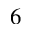<formula> <loc_0><loc_0><loc_500><loc_500>^ { 6 }</formula> 